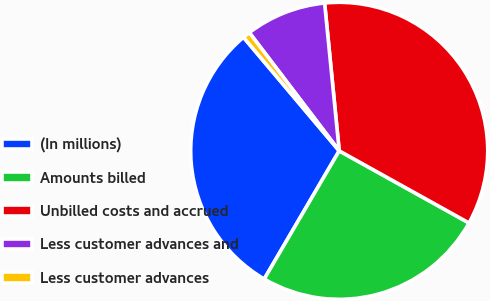<chart> <loc_0><loc_0><loc_500><loc_500><pie_chart><fcel>(In millions)<fcel>Amounts billed<fcel>Unbilled costs and accrued<fcel>Less customer advances and<fcel>Less customer advances<nl><fcel>30.43%<fcel>25.35%<fcel>34.64%<fcel>8.78%<fcel>0.8%<nl></chart> 